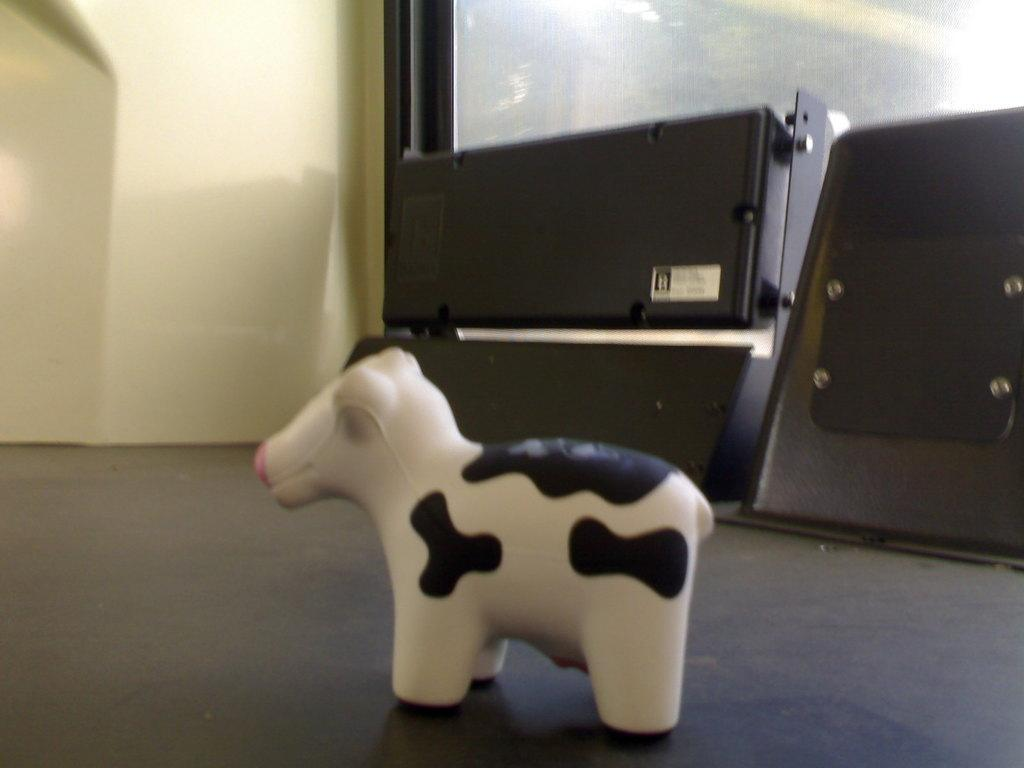What is on the floor in the image? There is a toy on the floor. What can be seen in the background of the image? There is a wall and objects visible in the background of the image. What type of battle is taking place in the image? There is no battle present in the image; it features a toy on the floor and a wall with objects in the background. 